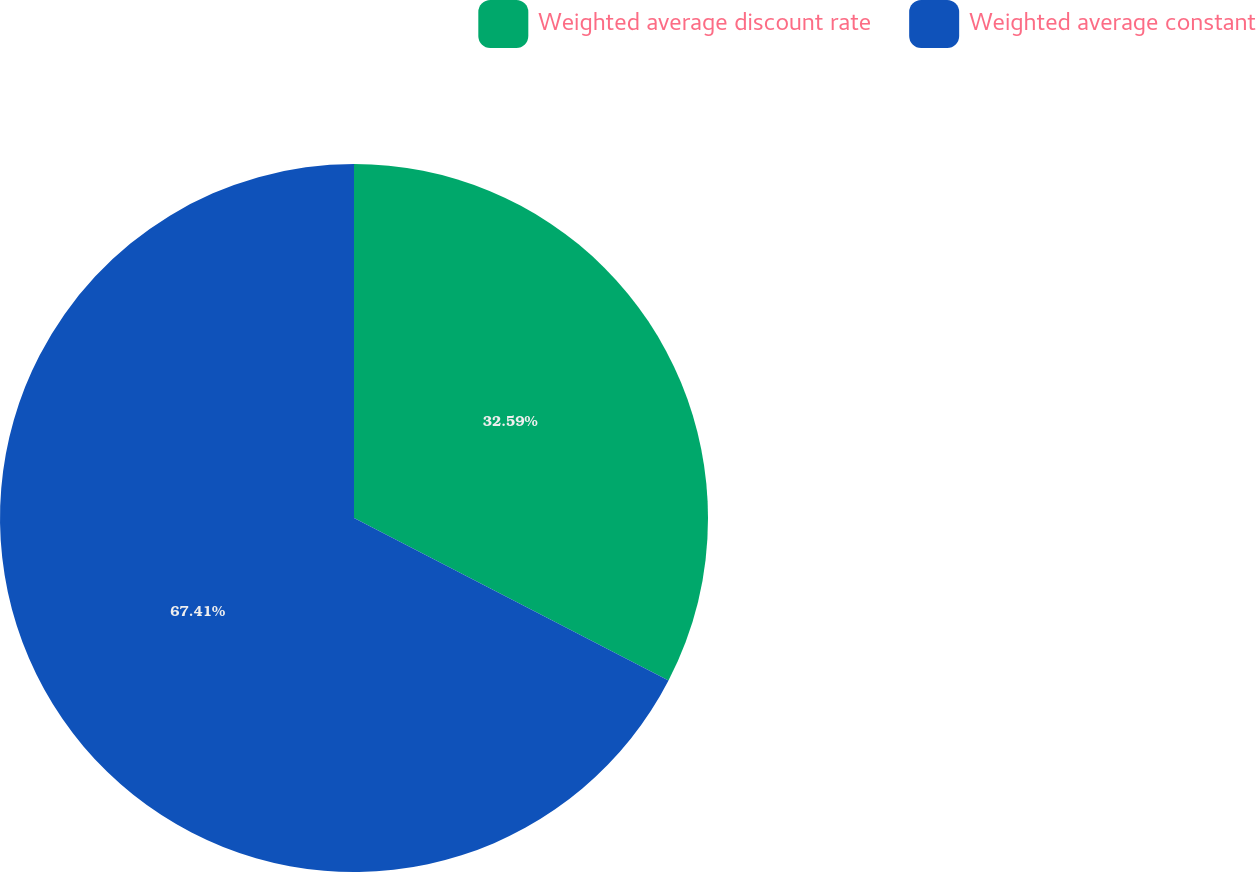<chart> <loc_0><loc_0><loc_500><loc_500><pie_chart><fcel>Weighted average discount rate<fcel>Weighted average constant<nl><fcel>32.59%<fcel>67.41%<nl></chart> 